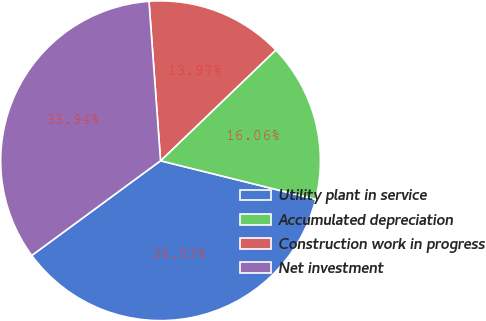Convert chart. <chart><loc_0><loc_0><loc_500><loc_500><pie_chart><fcel>Utility plant in service<fcel>Accumulated depreciation<fcel>Construction work in progress<fcel>Net investment<nl><fcel>36.03%<fcel>16.06%<fcel>13.97%<fcel>33.94%<nl></chart> 